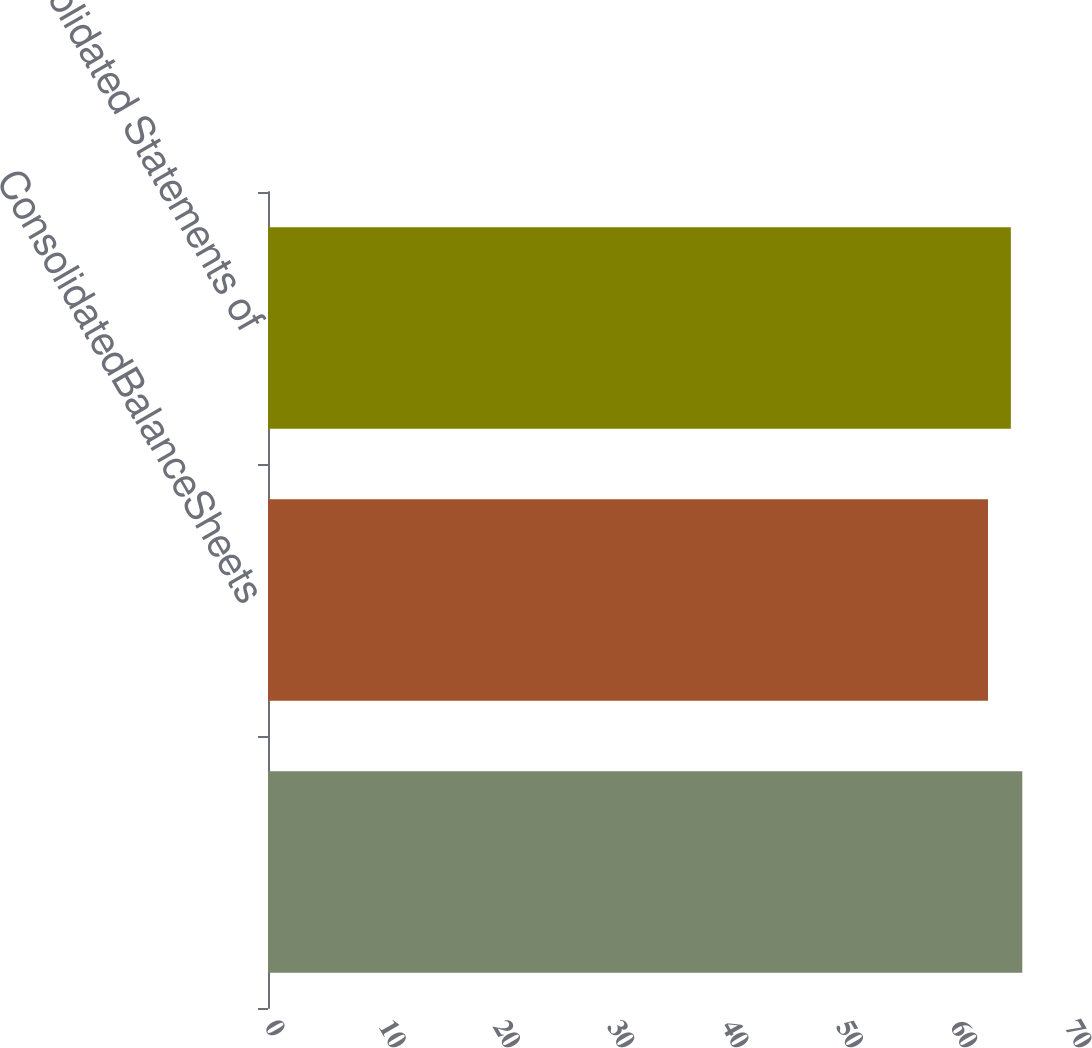Convert chart. <chart><loc_0><loc_0><loc_500><loc_500><bar_chart><ecel><fcel>ConsolidatedBalanceSheets<fcel>Consolidated Statements of<nl><fcel>66<fcel>63<fcel>65<nl></chart> 